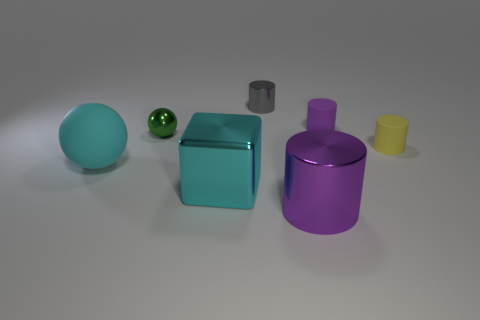Subtract all purple cylinders. How many were subtracted if there are1purple cylinders left? 1 Subtract all red cylinders. Subtract all yellow spheres. How many cylinders are left? 4 Add 1 yellow objects. How many objects exist? 8 Subtract all cylinders. How many objects are left? 3 Add 5 small objects. How many small objects are left? 9 Add 3 small objects. How many small objects exist? 7 Subtract 0 purple cubes. How many objects are left? 7 Subtract all tiny gray shiny objects. Subtract all green shiny objects. How many objects are left? 5 